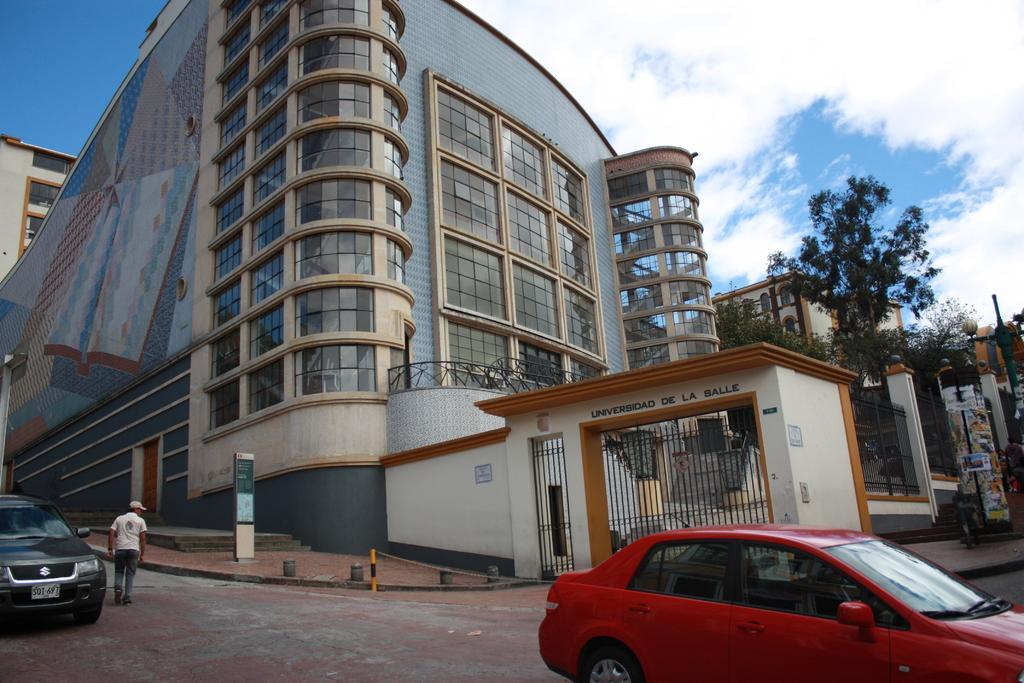How would you summarize this image in a sentence or two? In the right side there is a red car moving on the road, in the middle there is a very big building. At the top it's a cloudy sky. 